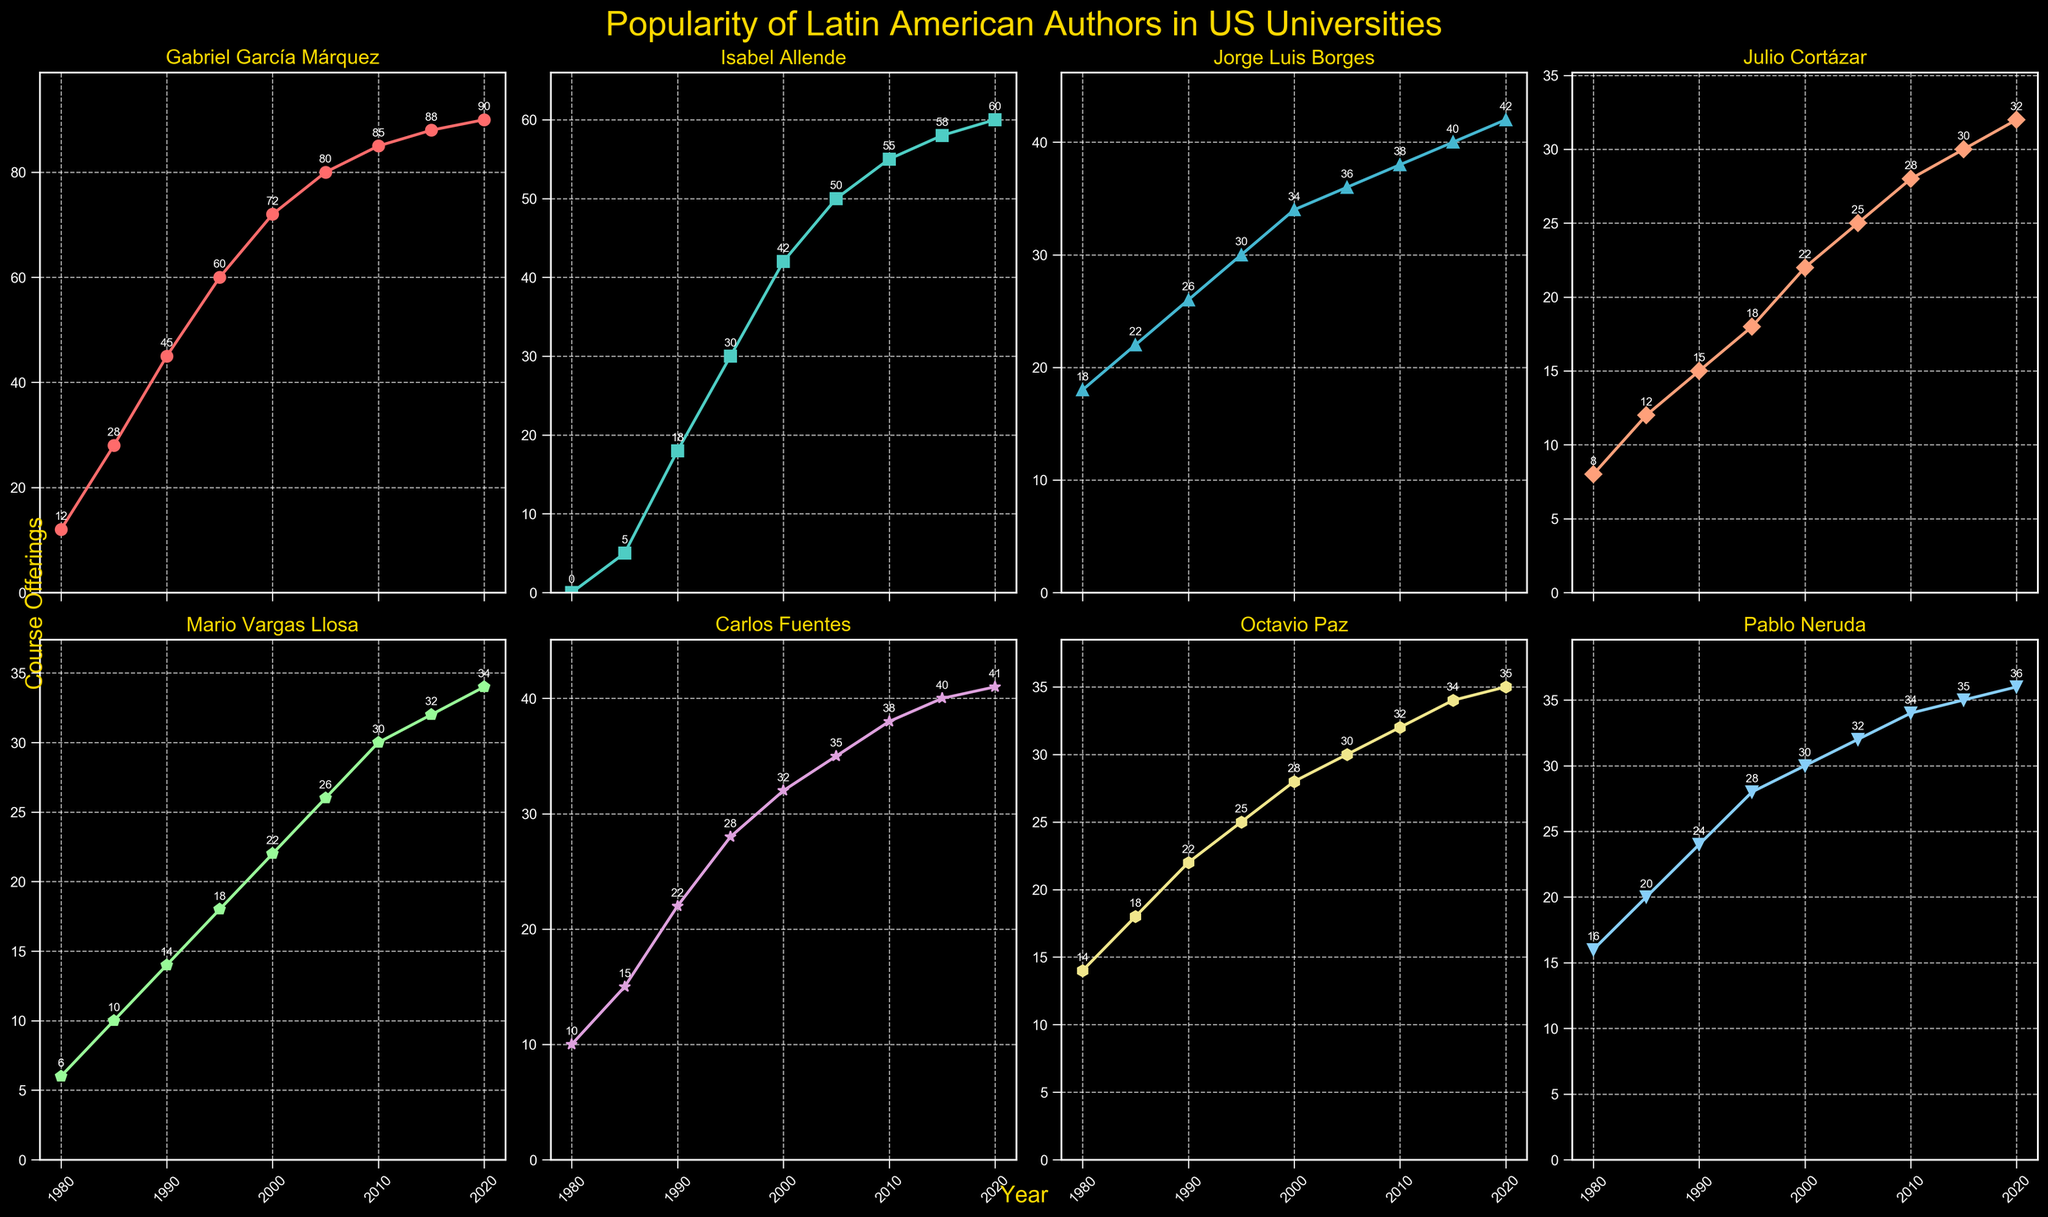Which author had the highest number of course offerings in 1980? Look at the first data point in each subplot for the year 1980. Identify the author with the highest value. Gabriel García Márquez had 18 course offerings in 1980.
Answer: Jorge Luis Borges Between 1990 and 2000, which author's popularity increased the most? Assess the difference between the 2000 and 1990 data points for each author. Gabriel García Márquez increased from 45 to 72, an increase of 27.
Answer: Gabriel García Márquez Which two authors had equal course offerings in 1990? In the subplot for the year 1990, look for authors with the same value. Octavio Paz and Jorge Luis Borges both had 22 course offerings.
Answer: Octavio Paz and Jorge Luis Borges What is the average number of course offerings for Mario Vargas Llosa from 1980 to 2020? Sum the data points for Mario Vargas Llosa from 1980 to 2020 and divide by the number of data points. The values are 6, 10, 14, 18, 22, 26, 30, 32, 34; sum equals 182. Average is 182/9 = 20.22
Answer: 20.22 Which author's popularity plateaued the earliest? Look for the author whose course offerings show the least growth over two consecutive intervals. Carlos Fuentes' values from 2010 to 2020 are very close: 38, 40, 41, suggesting a plateau.
Answer: Carlos Fuentes How does Gabriel García Márquez's popularity in 2000 compare to Isabel Allende's in 2020? Compare the data points for Gabriel García Márquez in 2000 (72) to Isabel Allende in 2020 (60). Gabriel García Márquez had 12 more course offerings.
Answer: Gabriel García Márquez had 12 more course offerings What is the combined number of course offerings for Pablo Neruda and Isabel Allende in 2015? Add the data points for Pablo Neruda and Isabel Allende in 2015. For Pablo Neruda: 35, for Isabel Allende: 58. Combined: 35 + 58 = 93
Answer: 93 Which author's course offerings do not show any decreases from 1980 to 2020? Look for a subplot where the values only increase or stay the same over time. Gabriel García Márquez's offerings steadily increase from 12 in 1980 to 90 in 2020.
Answer: Gabriel García Márquez What is the overall trend in popularity for Jorge Luis Borges from 1980 to 2020? Observe the data points for Jorge Luis Borges from 1980 to 2020. The values are consistently increasing from 18 in 1980 to 42 in 2020.
Answer: Increasing 